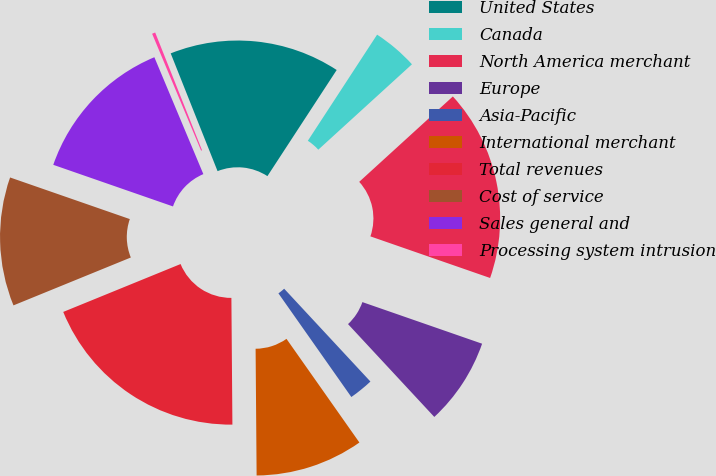Convert chart. <chart><loc_0><loc_0><loc_500><loc_500><pie_chart><fcel>United States<fcel>Canada<fcel>North America merchant<fcel>Europe<fcel>Asia-Pacific<fcel>International merchant<fcel>Total revenues<fcel>Cost of service<fcel>Sales general and<fcel>Processing system intrusion<nl><fcel>15.23%<fcel>4.03%<fcel>17.09%<fcel>7.76%<fcel>2.16%<fcel>9.63%<fcel>18.96%<fcel>11.49%<fcel>13.36%<fcel>0.29%<nl></chart> 